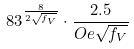Convert formula to latex. <formula><loc_0><loc_0><loc_500><loc_500>8 3 ^ { \frac { 8 } { 2 \sqrt { f _ { V } } } } \cdot \frac { 2 . 5 } { O e \sqrt { f _ { V } } }</formula> 